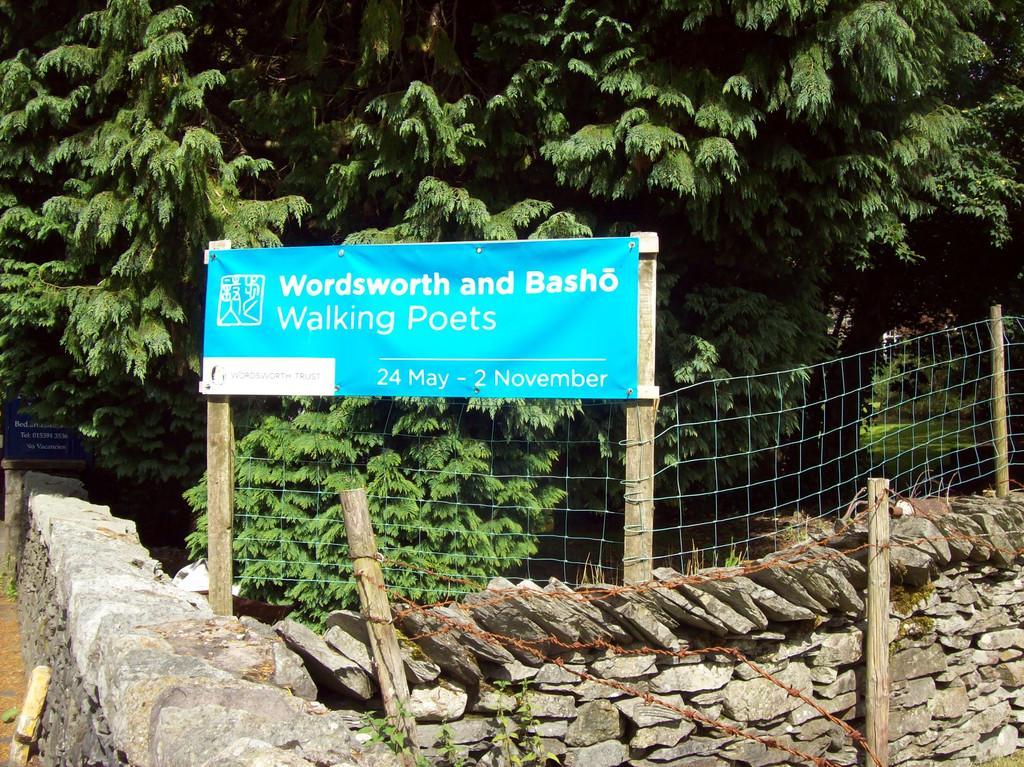In one or two sentences, can you explain what this image depicts? In this picture we can see the trees, fence, poles, wall, stones, banner. On the left side of the picture we can see a board with some information. 